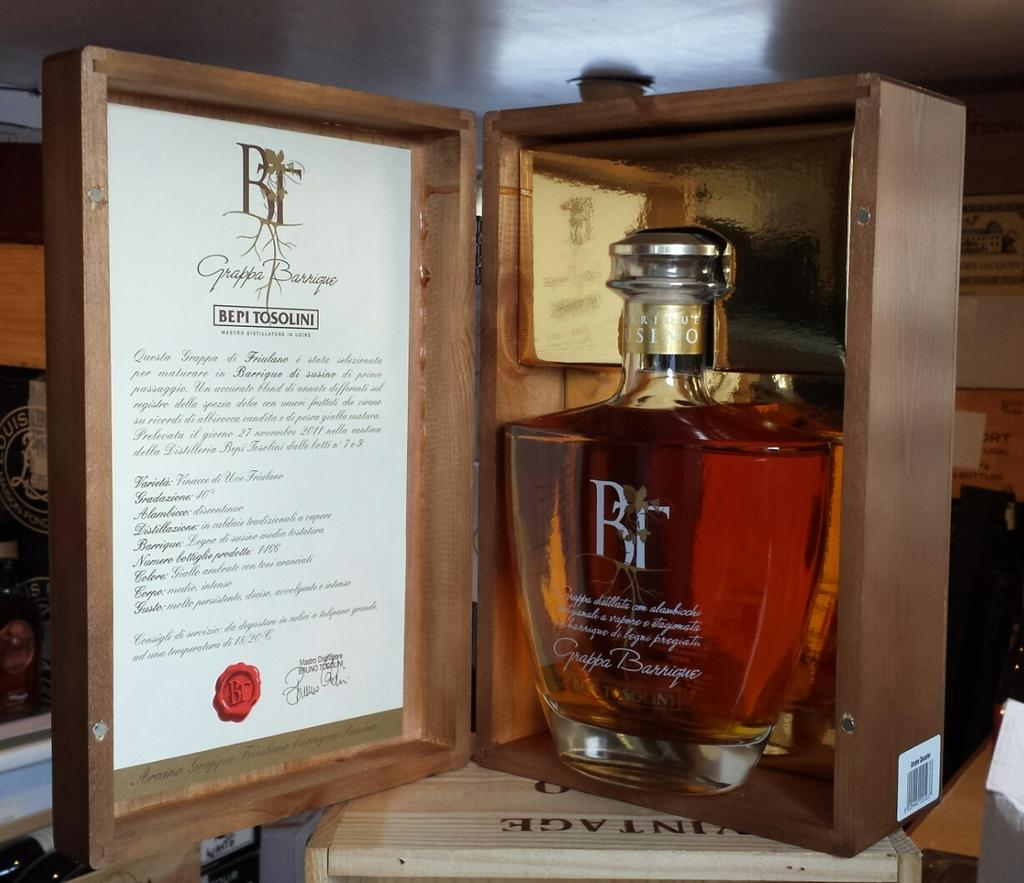<image>
Create a compact narrative representing the image presented. Bepi Tosolini branded alcohol with documentation in a wooden case. 